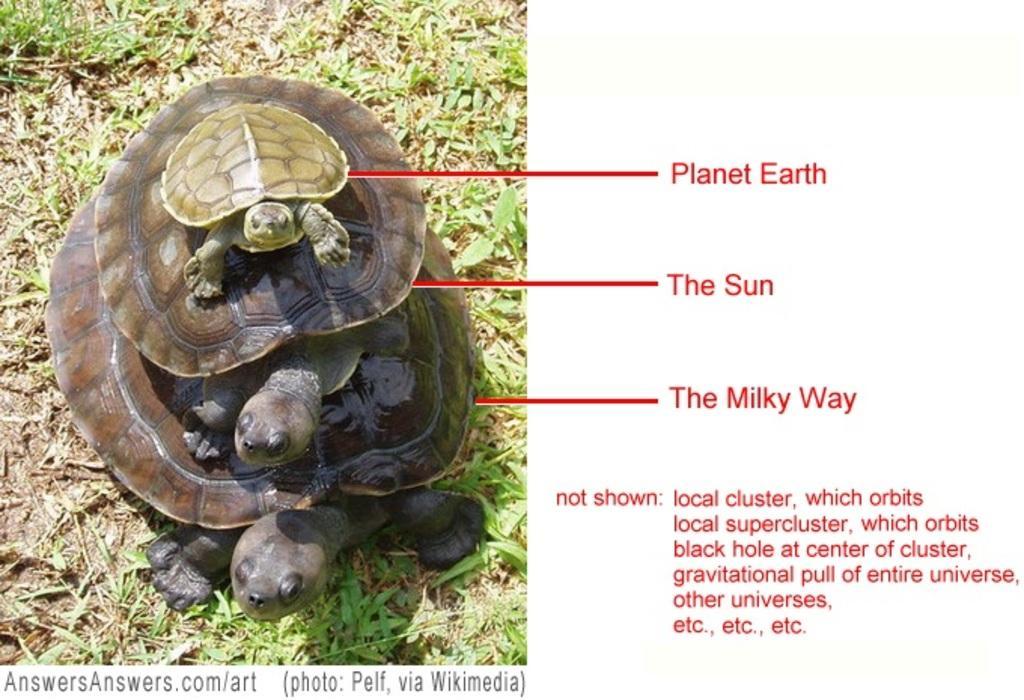How would you summarize this image in a sentence or two? In this image I can see three turtles are standing on the grass. This image is taken during a day. 